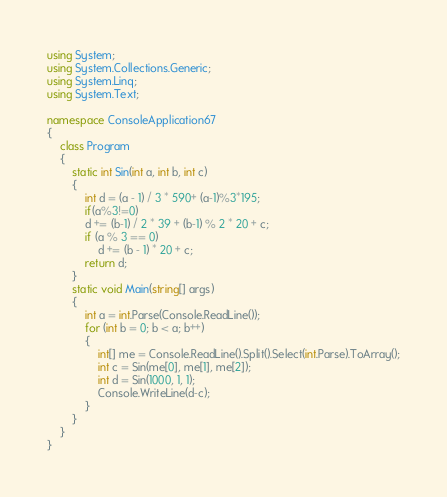<code> <loc_0><loc_0><loc_500><loc_500><_C#_>using System;
using System.Collections.Generic;
using System.Linq;
using System.Text;

namespace ConsoleApplication67
{
    class Program
    {
        static int Sin(int a, int b, int c)
        {
            int d = (a - 1) / 3 * 590+ (a-1)%3*195;
            if(a%3!=0)
            d += (b-1) / 2 * 39 + (b-1) % 2 * 20 + c;
            if (a % 3 == 0)
                d += (b - 1) * 20 + c;
            return d;
        }
        static void Main(string[] args)
        {
            int a = int.Parse(Console.ReadLine());
            for (int b = 0; b < a; b++)
            {
                int[] me = Console.ReadLine().Split().Select(int.Parse).ToArray();
                int c = Sin(me[0], me[1], me[2]);
                int d = Sin(1000, 1, 1);
                Console.WriteLine(d-c);
            }
        }
    }
}</code> 